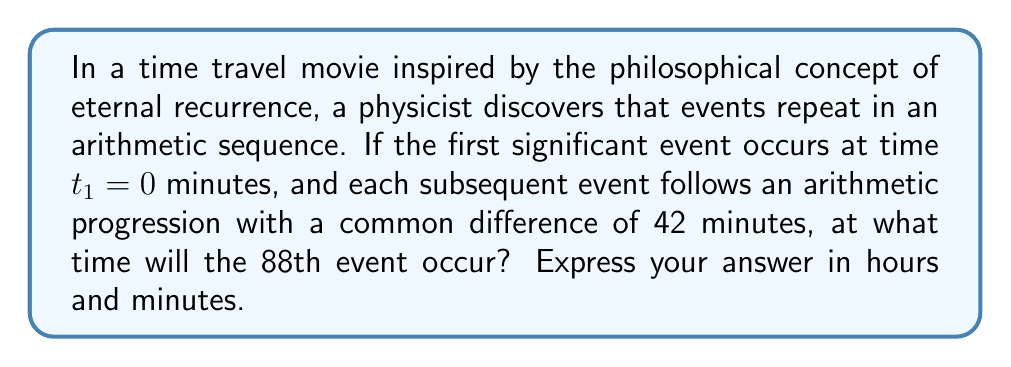Could you help me with this problem? Let's approach this step-by-step:

1) We are dealing with an arithmetic sequence where:
   $a_1 = 0$ (first term)
   $d = 42$ (common difference)
   $n = 88$ (we want to find the 88th term)

2) The general formula for the nth term of an arithmetic sequence is:
   $a_n = a_1 + (n - 1)d$

3) Substituting our values:
   $a_{88} = 0 + (88 - 1)42$

4) Simplifying:
   $a_{88} = 87 \times 42 = 3654$ minutes

5) To convert this to hours and minutes:
   $3654 \div 60 = 60$ hours with a remainder of $54$ minutes

6) 60 hours = 2 days + 12 hours

Therefore, the 88th event will occur at 60 hours and 54 minutes after the initial event, which is equivalent to 2 days, 12 hours, and 54 minutes.
Answer: 2 days, 12 hours, and 54 minutes 